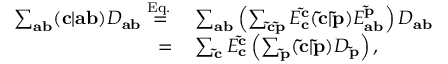<formula> <loc_0><loc_0><loc_500><loc_500>\begin{array} { r l } { \sum _ { a b } ( c | a b ) D _ { a b } \overset { E q . \, } { = } } & \sum _ { a b } \left ( \sum _ { \tilde { c } \tilde { p } } E _ { c } ^ { \tilde { c } } ( \tilde { c } | \tilde { p } ) E _ { a b } ^ { \tilde { p } } \right ) D _ { a b } } \\ { = } & \sum _ { \tilde { c } } E _ { c } ^ { \tilde { c } } \left ( \sum _ { \tilde { p } } ( \tilde { c } | \tilde { p } ) D _ { \tilde { p } } \right ) , } \end{array}</formula> 